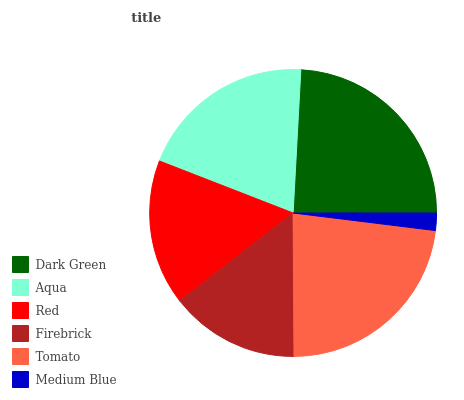Is Medium Blue the minimum?
Answer yes or no. Yes. Is Dark Green the maximum?
Answer yes or no. Yes. Is Aqua the minimum?
Answer yes or no. No. Is Aqua the maximum?
Answer yes or no. No. Is Dark Green greater than Aqua?
Answer yes or no. Yes. Is Aqua less than Dark Green?
Answer yes or no. Yes. Is Aqua greater than Dark Green?
Answer yes or no. No. Is Dark Green less than Aqua?
Answer yes or no. No. Is Aqua the high median?
Answer yes or no. Yes. Is Red the low median?
Answer yes or no. Yes. Is Medium Blue the high median?
Answer yes or no. No. Is Firebrick the low median?
Answer yes or no. No. 